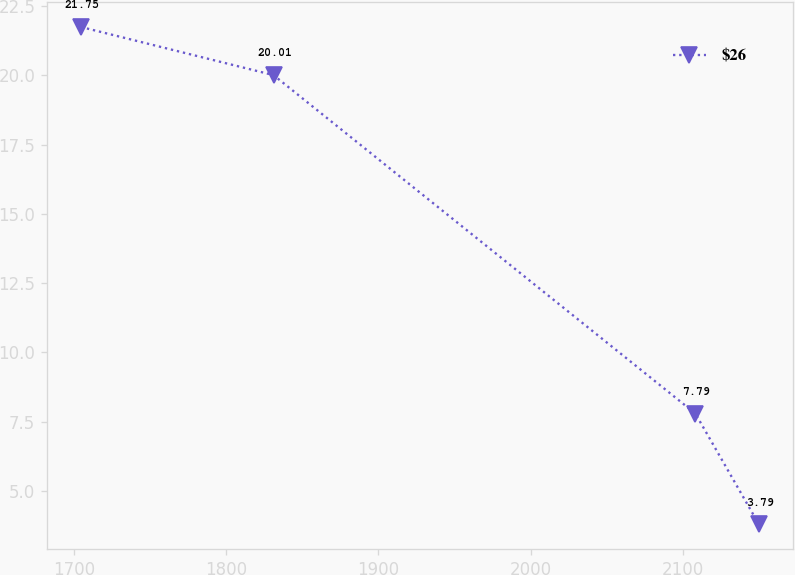Convert chart to OTSL. <chart><loc_0><loc_0><loc_500><loc_500><line_chart><ecel><fcel>$26<nl><fcel>1704.59<fcel>21.75<nl><fcel>1831.14<fcel>20.01<nl><fcel>2108.24<fcel>7.79<nl><fcel>2149.96<fcel>3.79<nl></chart> 